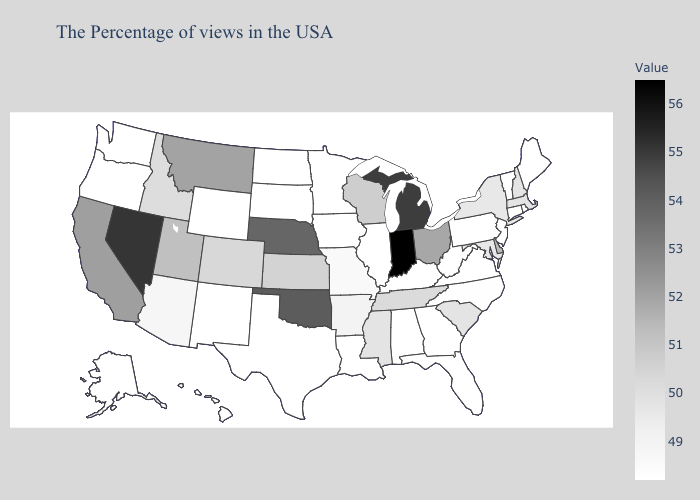Among the states that border Arkansas , which have the lowest value?
Keep it brief. Louisiana, Texas. Does Florida have the lowest value in the USA?
Concise answer only. Yes. Does Pennsylvania have the lowest value in the USA?
Concise answer only. Yes. Among the states that border California , does Oregon have the lowest value?
Concise answer only. Yes. Does North Dakota have the lowest value in the MidWest?
Concise answer only. Yes. Which states hav the highest value in the MidWest?
Short answer required. Indiana. Does Wyoming have the lowest value in the USA?
Write a very short answer. Yes. Among the states that border Oklahoma , does Kansas have the lowest value?
Concise answer only. No. 